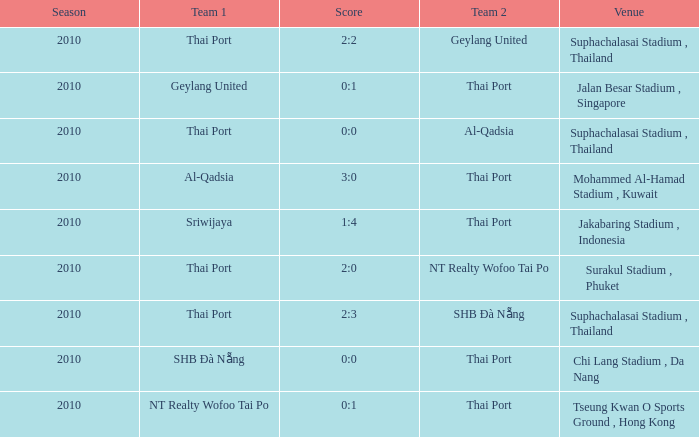What was the score for the game in which Al-Qadsia was Team 2? 0:0. 